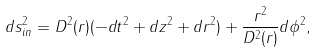Convert formula to latex. <formula><loc_0><loc_0><loc_500><loc_500>d s ^ { 2 } _ { i n } = D ^ { 2 } ( r ) ( - d t ^ { 2 } + d z ^ { 2 } + d r ^ { 2 } ) + \frac { r ^ { 2 } } { D ^ { 2 } ( r ) } d \phi ^ { 2 } ,</formula> 